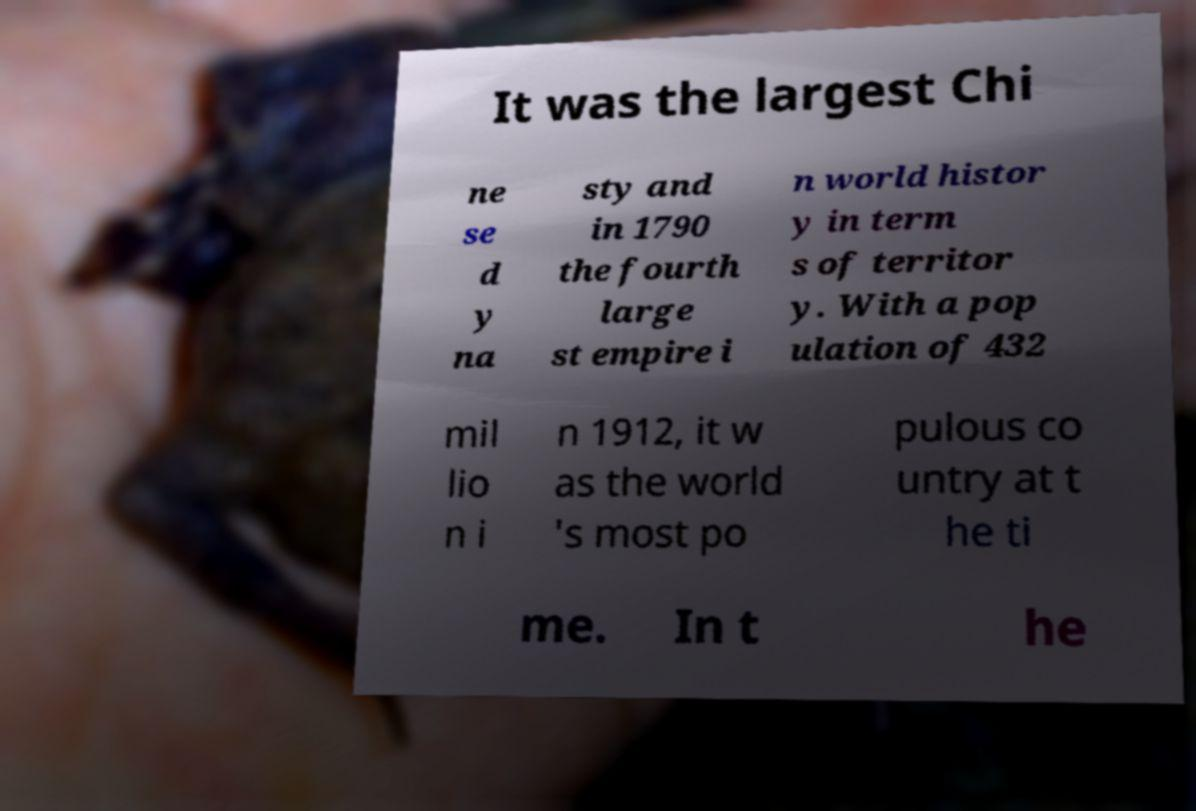For documentation purposes, I need the text within this image transcribed. Could you provide that? It was the largest Chi ne se d y na sty and in 1790 the fourth large st empire i n world histor y in term s of territor y. With a pop ulation of 432 mil lio n i n 1912, it w as the world 's most po pulous co untry at t he ti me. In t he 